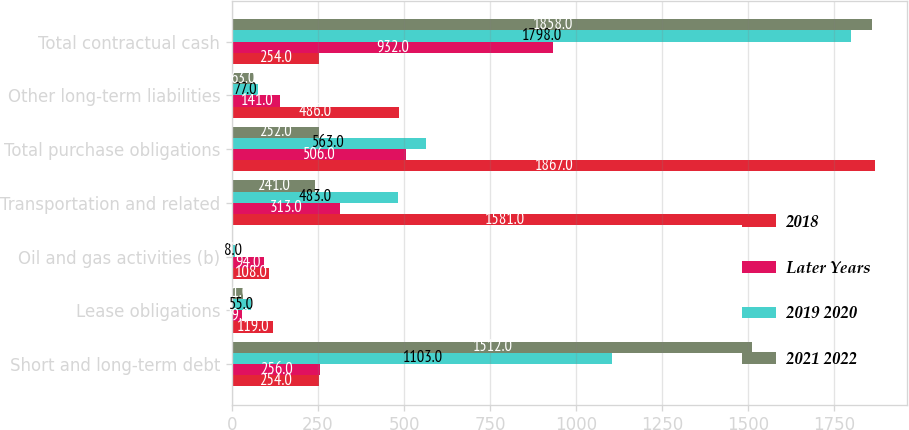Convert chart to OTSL. <chart><loc_0><loc_0><loc_500><loc_500><stacked_bar_chart><ecel><fcel>Short and long-term debt<fcel>Lease obligations<fcel>Oil and gas activities (b)<fcel>Transportation and related<fcel>Total purchase obligations<fcel>Other long-term liabilities<fcel>Total contractual cash<nl><fcel>2018<fcel>254<fcel>119<fcel>108<fcel>1581<fcel>1867<fcel>486<fcel>254<nl><fcel>Later Years<fcel>256<fcel>29<fcel>94<fcel>313<fcel>506<fcel>141<fcel>932<nl><fcel>2019 2020<fcel>1103<fcel>55<fcel>8<fcel>483<fcel>563<fcel>77<fcel>1798<nl><fcel>2021 2022<fcel>1512<fcel>31<fcel>4<fcel>241<fcel>252<fcel>63<fcel>1858<nl></chart> 